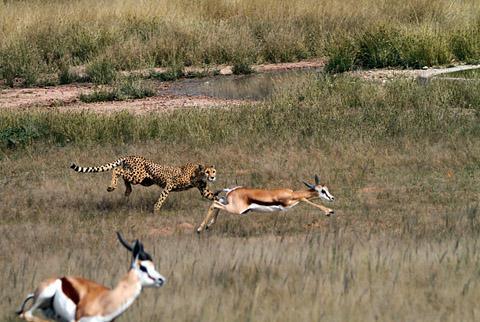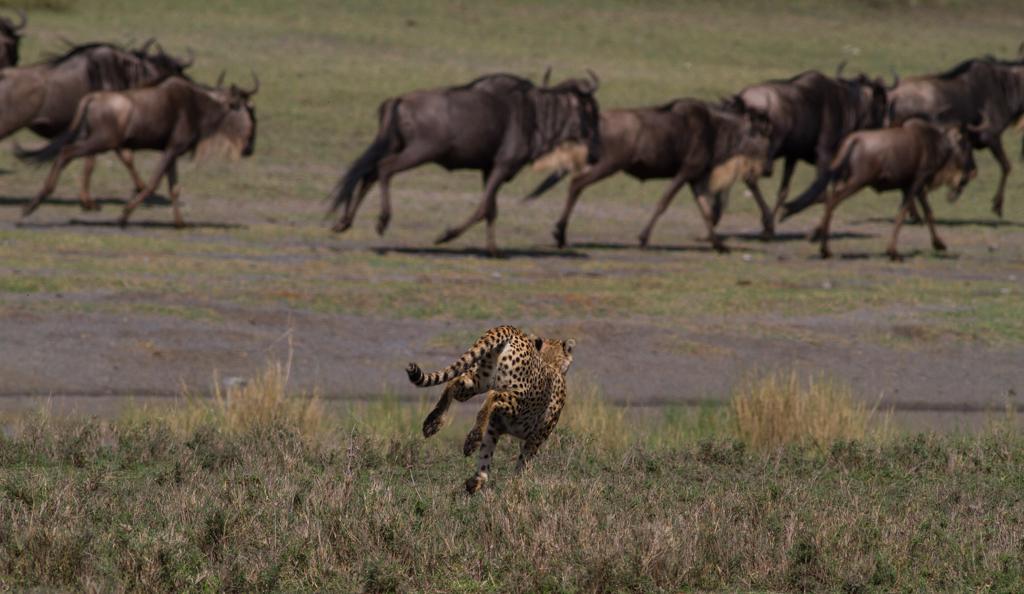The first image is the image on the left, the second image is the image on the right. Assess this claim about the two images: "An image shows a back-turned cheetah running toward a herd of fleeing horned animals, which are kicking up clouds of dust.". Correct or not? Answer yes or no. No. The first image is the image on the left, the second image is the image on the right. Evaluate the accuracy of this statement regarding the images: "Both images show a cheetah chasing potential prey.". Is it true? Answer yes or no. Yes. 